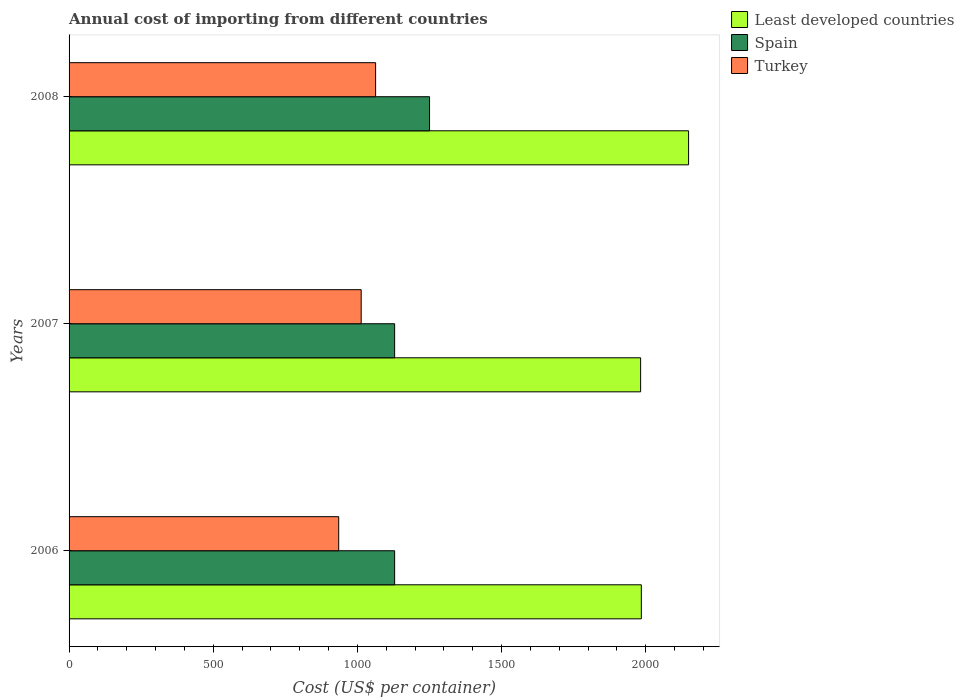How many different coloured bars are there?
Offer a very short reply. 3. Are the number of bars per tick equal to the number of legend labels?
Make the answer very short. Yes. How many bars are there on the 2nd tick from the top?
Provide a short and direct response. 3. How many bars are there on the 2nd tick from the bottom?
Your response must be concise. 3. What is the label of the 3rd group of bars from the top?
Keep it short and to the point. 2006. In how many cases, is the number of bars for a given year not equal to the number of legend labels?
Provide a succinct answer. 0. What is the total annual cost of importing in Spain in 2006?
Offer a terse response. 1129. Across all years, what is the maximum total annual cost of importing in Turkey?
Make the answer very short. 1063. Across all years, what is the minimum total annual cost of importing in Spain?
Provide a short and direct response. 1129. What is the total total annual cost of importing in Least developed countries in the graph?
Provide a succinct answer. 6114.68. What is the difference between the total annual cost of importing in Turkey in 2006 and that in 2008?
Provide a succinct answer. -128. What is the difference between the total annual cost of importing in Spain in 2006 and the total annual cost of importing in Turkey in 2007?
Your response must be concise. 116. What is the average total annual cost of importing in Spain per year?
Your answer should be very brief. 1169.33. In the year 2006, what is the difference between the total annual cost of importing in Least developed countries and total annual cost of importing in Spain?
Provide a succinct answer. 855.41. In how many years, is the total annual cost of importing in Spain greater than 1300 US$?
Your response must be concise. 0. Is the difference between the total annual cost of importing in Least developed countries in 2006 and 2008 greater than the difference between the total annual cost of importing in Spain in 2006 and 2008?
Ensure brevity in your answer.  No. What is the difference between the highest and the second highest total annual cost of importing in Spain?
Offer a very short reply. 121. What is the difference between the highest and the lowest total annual cost of importing in Least developed countries?
Your answer should be compact. 166.27. In how many years, is the total annual cost of importing in Least developed countries greater than the average total annual cost of importing in Least developed countries taken over all years?
Provide a succinct answer. 1. Is the sum of the total annual cost of importing in Spain in 2006 and 2007 greater than the maximum total annual cost of importing in Least developed countries across all years?
Make the answer very short. Yes. What does the 2nd bar from the top in 2006 represents?
Your answer should be compact. Spain. What does the 1st bar from the bottom in 2008 represents?
Provide a succinct answer. Least developed countries. Is it the case that in every year, the sum of the total annual cost of importing in Turkey and total annual cost of importing in Least developed countries is greater than the total annual cost of importing in Spain?
Provide a succinct answer. Yes. How many bars are there?
Make the answer very short. 9. Are all the bars in the graph horizontal?
Provide a short and direct response. Yes. What is the difference between two consecutive major ticks on the X-axis?
Give a very brief answer. 500. What is the title of the graph?
Your response must be concise. Annual cost of importing from different countries. Does "Japan" appear as one of the legend labels in the graph?
Your answer should be very brief. No. What is the label or title of the X-axis?
Your response must be concise. Cost (US$ per container). What is the label or title of the Y-axis?
Your answer should be very brief. Years. What is the Cost (US$ per container) of Least developed countries in 2006?
Your answer should be compact. 1984.41. What is the Cost (US$ per container) of Spain in 2006?
Offer a very short reply. 1129. What is the Cost (US$ per container) in Turkey in 2006?
Your answer should be very brief. 935. What is the Cost (US$ per container) in Least developed countries in 2007?
Make the answer very short. 1982. What is the Cost (US$ per container) in Spain in 2007?
Offer a terse response. 1129. What is the Cost (US$ per container) in Turkey in 2007?
Your answer should be compact. 1013. What is the Cost (US$ per container) of Least developed countries in 2008?
Your answer should be very brief. 2148.27. What is the Cost (US$ per container) in Spain in 2008?
Offer a very short reply. 1250. What is the Cost (US$ per container) in Turkey in 2008?
Offer a terse response. 1063. Across all years, what is the maximum Cost (US$ per container) in Least developed countries?
Provide a succinct answer. 2148.27. Across all years, what is the maximum Cost (US$ per container) of Spain?
Your answer should be compact. 1250. Across all years, what is the maximum Cost (US$ per container) in Turkey?
Provide a short and direct response. 1063. Across all years, what is the minimum Cost (US$ per container) of Least developed countries?
Your answer should be very brief. 1982. Across all years, what is the minimum Cost (US$ per container) of Spain?
Make the answer very short. 1129. Across all years, what is the minimum Cost (US$ per container) of Turkey?
Your response must be concise. 935. What is the total Cost (US$ per container) of Least developed countries in the graph?
Offer a terse response. 6114.68. What is the total Cost (US$ per container) of Spain in the graph?
Your answer should be very brief. 3508. What is the total Cost (US$ per container) in Turkey in the graph?
Your answer should be very brief. 3011. What is the difference between the Cost (US$ per container) of Least developed countries in 2006 and that in 2007?
Your answer should be very brief. 2.41. What is the difference between the Cost (US$ per container) of Turkey in 2006 and that in 2007?
Keep it short and to the point. -78. What is the difference between the Cost (US$ per container) in Least developed countries in 2006 and that in 2008?
Your answer should be compact. -163.86. What is the difference between the Cost (US$ per container) of Spain in 2006 and that in 2008?
Your answer should be compact. -121. What is the difference between the Cost (US$ per container) in Turkey in 2006 and that in 2008?
Your answer should be compact. -128. What is the difference between the Cost (US$ per container) of Least developed countries in 2007 and that in 2008?
Give a very brief answer. -166.27. What is the difference between the Cost (US$ per container) in Spain in 2007 and that in 2008?
Give a very brief answer. -121. What is the difference between the Cost (US$ per container) in Least developed countries in 2006 and the Cost (US$ per container) in Spain in 2007?
Your answer should be compact. 855.41. What is the difference between the Cost (US$ per container) in Least developed countries in 2006 and the Cost (US$ per container) in Turkey in 2007?
Your answer should be very brief. 971.41. What is the difference between the Cost (US$ per container) in Spain in 2006 and the Cost (US$ per container) in Turkey in 2007?
Make the answer very short. 116. What is the difference between the Cost (US$ per container) in Least developed countries in 2006 and the Cost (US$ per container) in Spain in 2008?
Provide a succinct answer. 734.41. What is the difference between the Cost (US$ per container) in Least developed countries in 2006 and the Cost (US$ per container) in Turkey in 2008?
Your answer should be compact. 921.41. What is the difference between the Cost (US$ per container) of Least developed countries in 2007 and the Cost (US$ per container) of Spain in 2008?
Keep it short and to the point. 732. What is the difference between the Cost (US$ per container) of Least developed countries in 2007 and the Cost (US$ per container) of Turkey in 2008?
Your answer should be very brief. 919. What is the difference between the Cost (US$ per container) of Spain in 2007 and the Cost (US$ per container) of Turkey in 2008?
Provide a succinct answer. 66. What is the average Cost (US$ per container) in Least developed countries per year?
Ensure brevity in your answer.  2038.23. What is the average Cost (US$ per container) in Spain per year?
Offer a very short reply. 1169.33. What is the average Cost (US$ per container) of Turkey per year?
Offer a terse response. 1003.67. In the year 2006, what is the difference between the Cost (US$ per container) of Least developed countries and Cost (US$ per container) of Spain?
Give a very brief answer. 855.41. In the year 2006, what is the difference between the Cost (US$ per container) in Least developed countries and Cost (US$ per container) in Turkey?
Keep it short and to the point. 1049.41. In the year 2006, what is the difference between the Cost (US$ per container) in Spain and Cost (US$ per container) in Turkey?
Ensure brevity in your answer.  194. In the year 2007, what is the difference between the Cost (US$ per container) of Least developed countries and Cost (US$ per container) of Spain?
Give a very brief answer. 853. In the year 2007, what is the difference between the Cost (US$ per container) of Least developed countries and Cost (US$ per container) of Turkey?
Offer a terse response. 969. In the year 2007, what is the difference between the Cost (US$ per container) in Spain and Cost (US$ per container) in Turkey?
Your answer should be very brief. 116. In the year 2008, what is the difference between the Cost (US$ per container) of Least developed countries and Cost (US$ per container) of Spain?
Your answer should be compact. 898.27. In the year 2008, what is the difference between the Cost (US$ per container) in Least developed countries and Cost (US$ per container) in Turkey?
Your answer should be very brief. 1085.27. In the year 2008, what is the difference between the Cost (US$ per container) of Spain and Cost (US$ per container) of Turkey?
Offer a terse response. 187. What is the ratio of the Cost (US$ per container) in Least developed countries in 2006 to that in 2007?
Provide a succinct answer. 1. What is the ratio of the Cost (US$ per container) of Spain in 2006 to that in 2007?
Give a very brief answer. 1. What is the ratio of the Cost (US$ per container) of Turkey in 2006 to that in 2007?
Ensure brevity in your answer.  0.92. What is the ratio of the Cost (US$ per container) in Least developed countries in 2006 to that in 2008?
Your answer should be very brief. 0.92. What is the ratio of the Cost (US$ per container) of Spain in 2006 to that in 2008?
Offer a very short reply. 0.9. What is the ratio of the Cost (US$ per container) in Turkey in 2006 to that in 2008?
Your response must be concise. 0.88. What is the ratio of the Cost (US$ per container) of Least developed countries in 2007 to that in 2008?
Make the answer very short. 0.92. What is the ratio of the Cost (US$ per container) of Spain in 2007 to that in 2008?
Provide a short and direct response. 0.9. What is the ratio of the Cost (US$ per container) of Turkey in 2007 to that in 2008?
Give a very brief answer. 0.95. What is the difference between the highest and the second highest Cost (US$ per container) in Least developed countries?
Provide a succinct answer. 163.86. What is the difference between the highest and the second highest Cost (US$ per container) in Spain?
Give a very brief answer. 121. What is the difference between the highest and the second highest Cost (US$ per container) of Turkey?
Make the answer very short. 50. What is the difference between the highest and the lowest Cost (US$ per container) of Least developed countries?
Offer a terse response. 166.27. What is the difference between the highest and the lowest Cost (US$ per container) in Spain?
Keep it short and to the point. 121. What is the difference between the highest and the lowest Cost (US$ per container) of Turkey?
Provide a succinct answer. 128. 